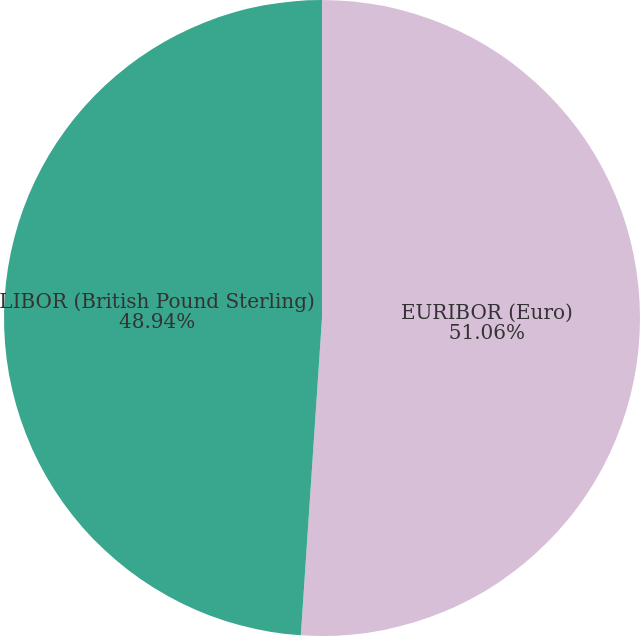Convert chart. <chart><loc_0><loc_0><loc_500><loc_500><pie_chart><fcel>EURIBOR (Euro)<fcel>LIBOR (British Pound Sterling)<nl><fcel>51.06%<fcel>48.94%<nl></chart> 